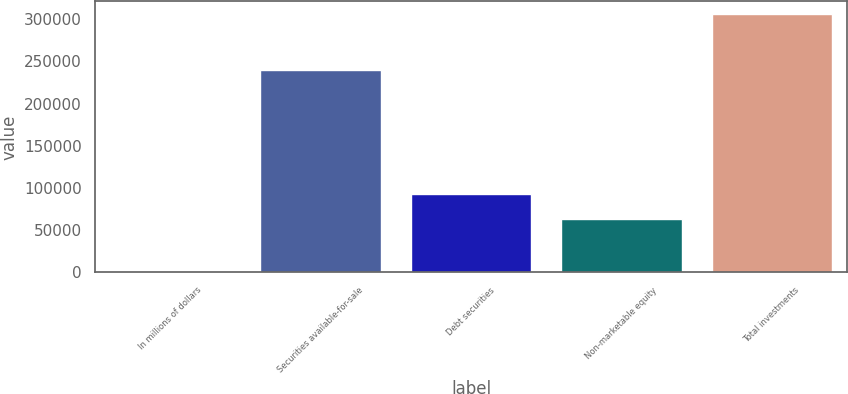Convert chart to OTSL. <chart><loc_0><loc_0><loc_500><loc_500><bar_chart><fcel>In millions of dollars<fcel>Securities available-for-sale<fcel>Debt securities<fcel>Non-marketable equity<fcel>Total investments<nl><fcel>2009<fcel>239599<fcel>93242<fcel>62831<fcel>306119<nl></chart> 